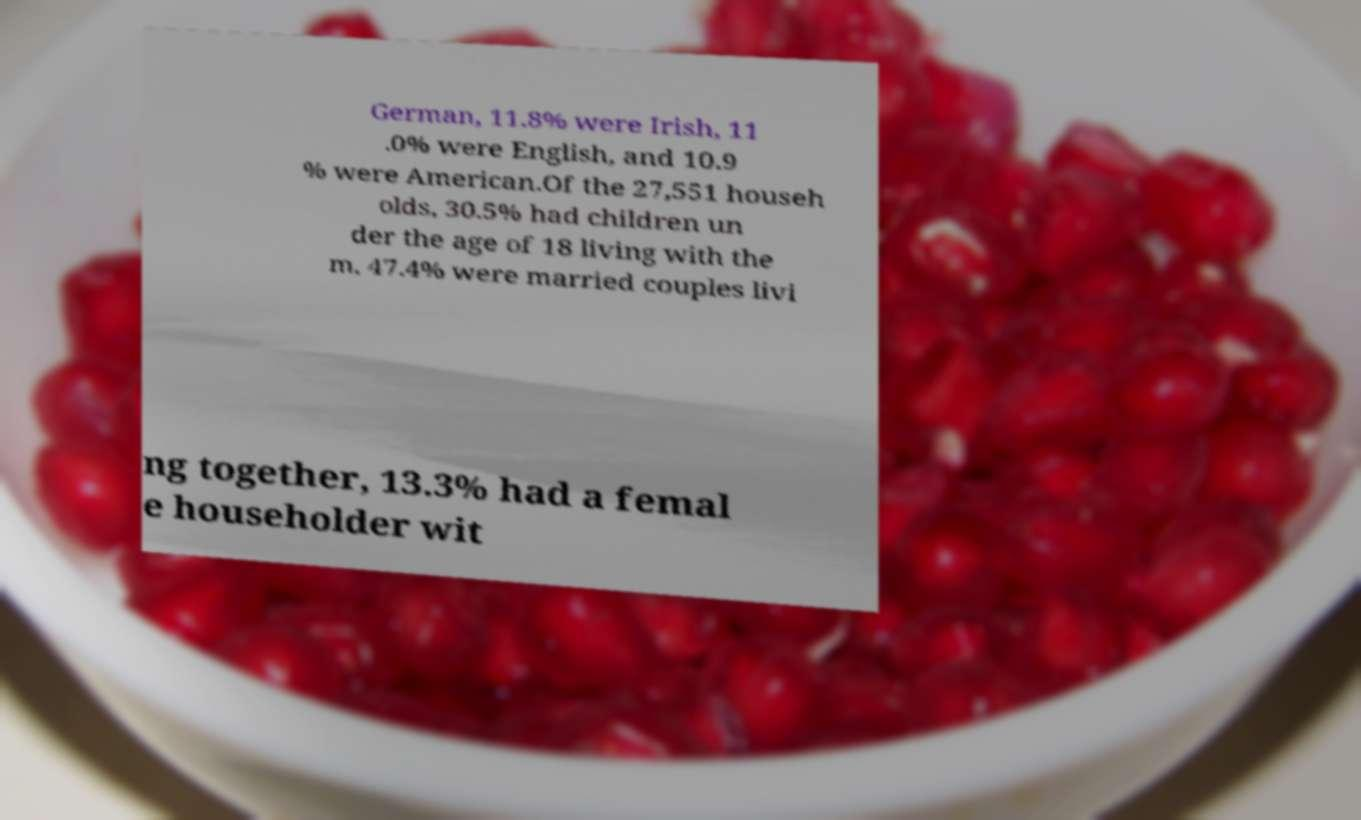Can you read and provide the text displayed in the image?This photo seems to have some interesting text. Can you extract and type it out for me? German, 11.8% were Irish, 11 .0% were English, and 10.9 % were American.Of the 27,551 househ olds, 30.5% had children un der the age of 18 living with the m, 47.4% were married couples livi ng together, 13.3% had a femal e householder wit 